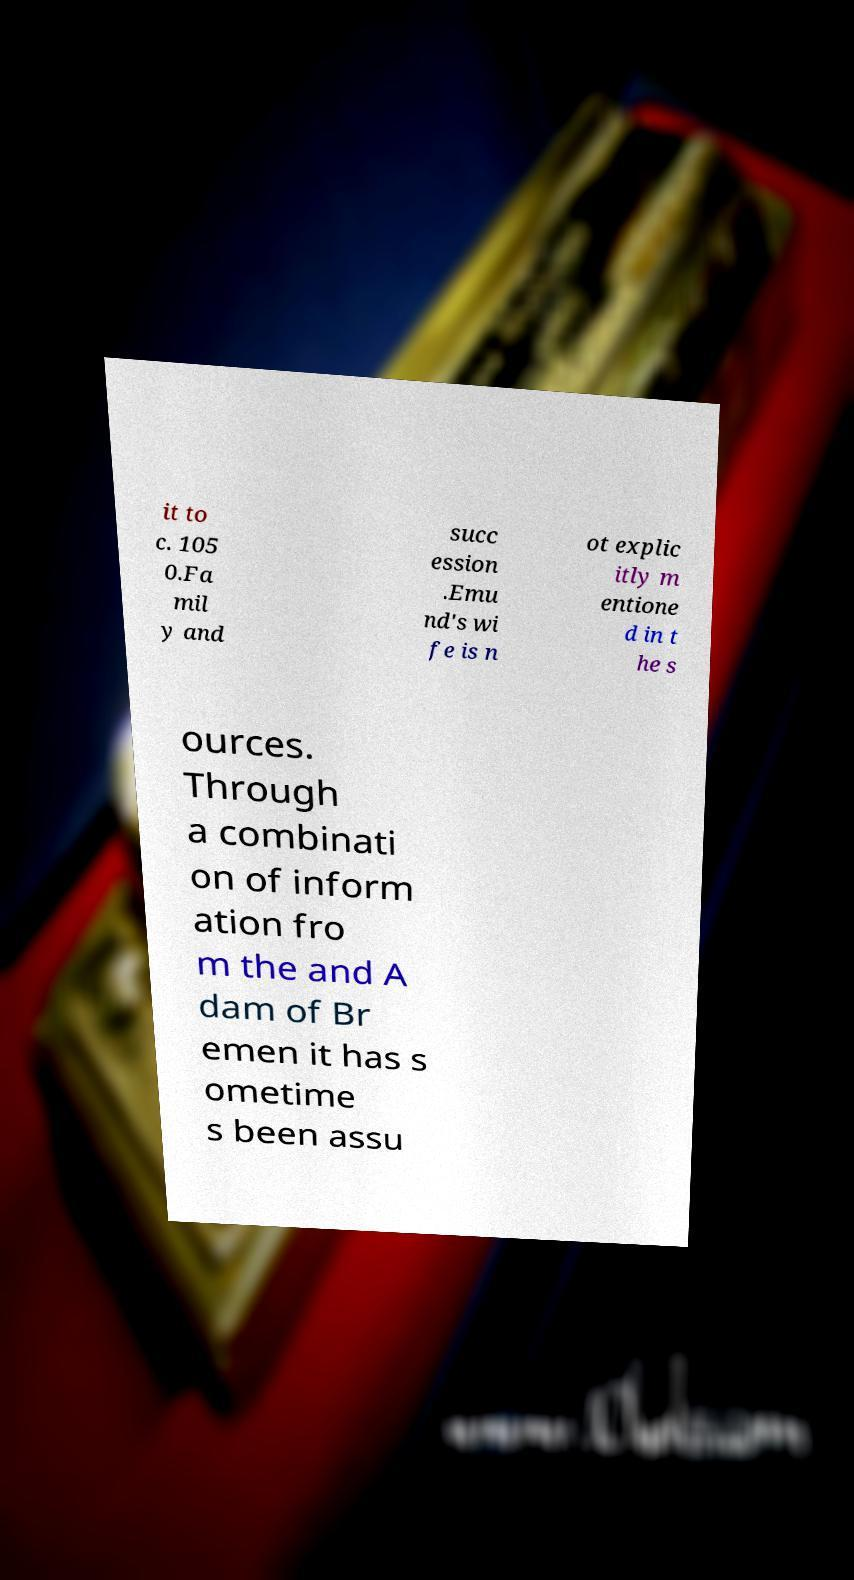I need the written content from this picture converted into text. Can you do that? it to c. 105 0.Fa mil y and succ ession .Emu nd's wi fe is n ot explic itly m entione d in t he s ources. Through a combinati on of inform ation fro m the and A dam of Br emen it has s ometime s been assu 